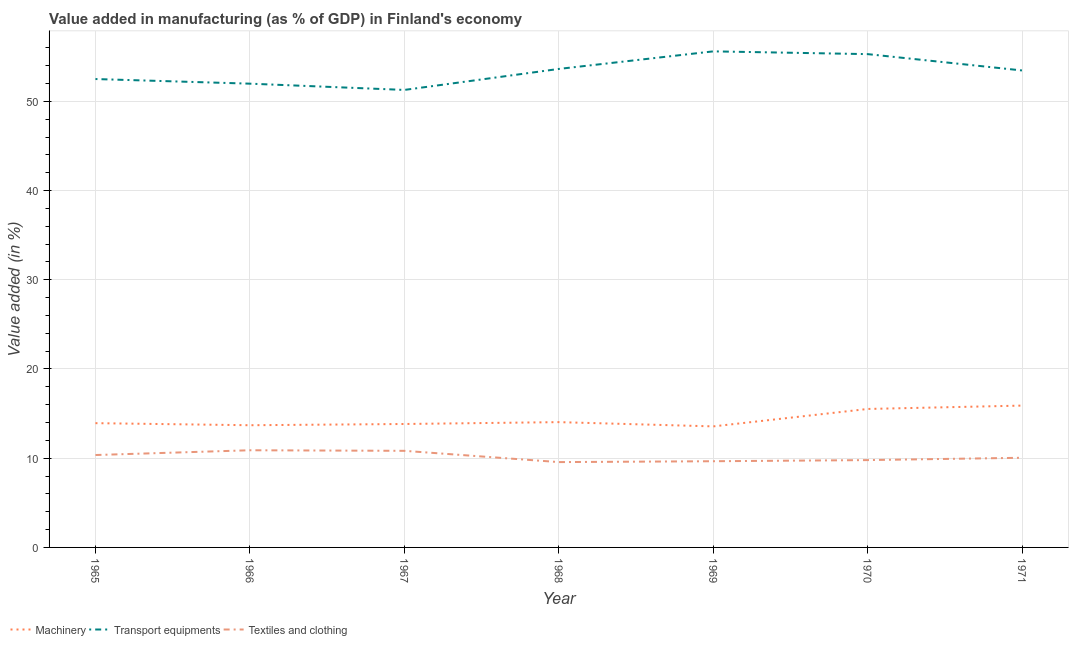What is the value added in manufacturing transport equipments in 1970?
Offer a very short reply. 55.29. Across all years, what is the maximum value added in manufacturing machinery?
Make the answer very short. 15.9. Across all years, what is the minimum value added in manufacturing textile and clothing?
Offer a terse response. 9.56. In which year was the value added in manufacturing textile and clothing maximum?
Provide a short and direct response. 1966. In which year was the value added in manufacturing textile and clothing minimum?
Your answer should be very brief. 1968. What is the total value added in manufacturing machinery in the graph?
Provide a short and direct response. 100.49. What is the difference between the value added in manufacturing machinery in 1966 and that in 1968?
Your response must be concise. -0.35. What is the difference between the value added in manufacturing machinery in 1966 and the value added in manufacturing transport equipments in 1969?
Offer a very short reply. -41.9. What is the average value added in manufacturing textile and clothing per year?
Provide a succinct answer. 10.16. In the year 1967, what is the difference between the value added in manufacturing textile and clothing and value added in manufacturing machinery?
Keep it short and to the point. -3.01. In how many years, is the value added in manufacturing machinery greater than 36 %?
Make the answer very short. 0. What is the ratio of the value added in manufacturing machinery in 1965 to that in 1968?
Your answer should be compact. 0.99. Is the difference between the value added in manufacturing machinery in 1966 and 1971 greater than the difference between the value added in manufacturing textile and clothing in 1966 and 1971?
Provide a succinct answer. No. What is the difference between the highest and the second highest value added in manufacturing textile and clothing?
Provide a short and direct response. 0.06. What is the difference between the highest and the lowest value added in manufacturing transport equipments?
Keep it short and to the point. 4.32. Is it the case that in every year, the sum of the value added in manufacturing machinery and value added in manufacturing transport equipments is greater than the value added in manufacturing textile and clothing?
Offer a terse response. Yes. Is the value added in manufacturing textile and clothing strictly less than the value added in manufacturing transport equipments over the years?
Offer a very short reply. Yes. Does the graph contain any zero values?
Provide a succinct answer. No. Does the graph contain grids?
Make the answer very short. Yes. Where does the legend appear in the graph?
Provide a short and direct response. Bottom left. How are the legend labels stacked?
Your answer should be compact. Horizontal. What is the title of the graph?
Provide a short and direct response. Value added in manufacturing (as % of GDP) in Finland's economy. Does "Secondary" appear as one of the legend labels in the graph?
Provide a succinct answer. No. What is the label or title of the X-axis?
Provide a succinct answer. Year. What is the label or title of the Y-axis?
Give a very brief answer. Value added (in %). What is the Value added (in %) of Machinery in 1965?
Make the answer very short. 13.93. What is the Value added (in %) in Transport equipments in 1965?
Your response must be concise. 52.5. What is the Value added (in %) in Textiles and clothing in 1965?
Your answer should be very brief. 10.36. What is the Value added (in %) of Machinery in 1966?
Give a very brief answer. 13.7. What is the Value added (in %) of Transport equipments in 1966?
Offer a terse response. 51.98. What is the Value added (in %) in Textiles and clothing in 1966?
Your response must be concise. 10.89. What is the Value added (in %) of Machinery in 1967?
Provide a short and direct response. 13.83. What is the Value added (in %) in Transport equipments in 1967?
Give a very brief answer. 51.28. What is the Value added (in %) in Textiles and clothing in 1967?
Keep it short and to the point. 10.83. What is the Value added (in %) of Machinery in 1968?
Your answer should be very brief. 14.04. What is the Value added (in %) in Transport equipments in 1968?
Your answer should be very brief. 53.63. What is the Value added (in %) in Textiles and clothing in 1968?
Offer a very short reply. 9.56. What is the Value added (in %) in Machinery in 1969?
Offer a terse response. 13.57. What is the Value added (in %) of Transport equipments in 1969?
Offer a very short reply. 55.6. What is the Value added (in %) in Textiles and clothing in 1969?
Your response must be concise. 9.66. What is the Value added (in %) in Machinery in 1970?
Give a very brief answer. 15.52. What is the Value added (in %) of Transport equipments in 1970?
Offer a terse response. 55.29. What is the Value added (in %) in Textiles and clothing in 1970?
Provide a succinct answer. 9.79. What is the Value added (in %) of Machinery in 1971?
Make the answer very short. 15.9. What is the Value added (in %) in Transport equipments in 1971?
Provide a short and direct response. 53.46. What is the Value added (in %) of Textiles and clothing in 1971?
Offer a very short reply. 10.05. Across all years, what is the maximum Value added (in %) in Machinery?
Offer a very short reply. 15.9. Across all years, what is the maximum Value added (in %) of Transport equipments?
Offer a very short reply. 55.6. Across all years, what is the maximum Value added (in %) in Textiles and clothing?
Your response must be concise. 10.89. Across all years, what is the minimum Value added (in %) in Machinery?
Your answer should be compact. 13.57. Across all years, what is the minimum Value added (in %) of Transport equipments?
Offer a very short reply. 51.28. Across all years, what is the minimum Value added (in %) in Textiles and clothing?
Keep it short and to the point. 9.56. What is the total Value added (in %) of Machinery in the graph?
Your response must be concise. 100.49. What is the total Value added (in %) of Transport equipments in the graph?
Your answer should be very brief. 373.74. What is the total Value added (in %) in Textiles and clothing in the graph?
Your answer should be very brief. 71.14. What is the difference between the Value added (in %) in Machinery in 1965 and that in 1966?
Provide a succinct answer. 0.23. What is the difference between the Value added (in %) of Transport equipments in 1965 and that in 1966?
Offer a very short reply. 0.52. What is the difference between the Value added (in %) in Textiles and clothing in 1965 and that in 1966?
Ensure brevity in your answer.  -0.53. What is the difference between the Value added (in %) in Machinery in 1965 and that in 1967?
Offer a terse response. 0.09. What is the difference between the Value added (in %) in Transport equipments in 1965 and that in 1967?
Ensure brevity in your answer.  1.22. What is the difference between the Value added (in %) of Textiles and clothing in 1965 and that in 1967?
Your answer should be very brief. -0.47. What is the difference between the Value added (in %) in Machinery in 1965 and that in 1968?
Your answer should be compact. -0.12. What is the difference between the Value added (in %) of Transport equipments in 1965 and that in 1968?
Offer a very short reply. -1.13. What is the difference between the Value added (in %) in Textiles and clothing in 1965 and that in 1968?
Ensure brevity in your answer.  0.79. What is the difference between the Value added (in %) of Machinery in 1965 and that in 1969?
Provide a short and direct response. 0.36. What is the difference between the Value added (in %) in Transport equipments in 1965 and that in 1969?
Your response must be concise. -3.1. What is the difference between the Value added (in %) in Textiles and clothing in 1965 and that in 1969?
Offer a terse response. 0.7. What is the difference between the Value added (in %) in Machinery in 1965 and that in 1970?
Provide a succinct answer. -1.59. What is the difference between the Value added (in %) of Transport equipments in 1965 and that in 1970?
Provide a succinct answer. -2.79. What is the difference between the Value added (in %) in Textiles and clothing in 1965 and that in 1970?
Give a very brief answer. 0.57. What is the difference between the Value added (in %) in Machinery in 1965 and that in 1971?
Provide a succinct answer. -1.97. What is the difference between the Value added (in %) of Transport equipments in 1965 and that in 1971?
Offer a terse response. -0.96. What is the difference between the Value added (in %) of Textiles and clothing in 1965 and that in 1971?
Keep it short and to the point. 0.31. What is the difference between the Value added (in %) of Machinery in 1966 and that in 1967?
Give a very brief answer. -0.14. What is the difference between the Value added (in %) of Transport equipments in 1966 and that in 1967?
Make the answer very short. 0.7. What is the difference between the Value added (in %) in Textiles and clothing in 1966 and that in 1967?
Your answer should be compact. 0.06. What is the difference between the Value added (in %) of Machinery in 1966 and that in 1968?
Your answer should be very brief. -0.35. What is the difference between the Value added (in %) of Transport equipments in 1966 and that in 1968?
Your answer should be very brief. -1.65. What is the difference between the Value added (in %) of Textiles and clothing in 1966 and that in 1968?
Offer a terse response. 1.33. What is the difference between the Value added (in %) in Machinery in 1966 and that in 1969?
Your answer should be very brief. 0.13. What is the difference between the Value added (in %) in Transport equipments in 1966 and that in 1969?
Give a very brief answer. -3.62. What is the difference between the Value added (in %) in Textiles and clothing in 1966 and that in 1969?
Make the answer very short. 1.23. What is the difference between the Value added (in %) in Machinery in 1966 and that in 1970?
Offer a very short reply. -1.82. What is the difference between the Value added (in %) of Transport equipments in 1966 and that in 1970?
Provide a succinct answer. -3.31. What is the difference between the Value added (in %) of Textiles and clothing in 1966 and that in 1970?
Provide a succinct answer. 1.1. What is the difference between the Value added (in %) in Machinery in 1966 and that in 1971?
Keep it short and to the point. -2.2. What is the difference between the Value added (in %) of Transport equipments in 1966 and that in 1971?
Provide a short and direct response. -1.48. What is the difference between the Value added (in %) in Textiles and clothing in 1966 and that in 1971?
Your answer should be compact. 0.84. What is the difference between the Value added (in %) of Machinery in 1967 and that in 1968?
Provide a short and direct response. -0.21. What is the difference between the Value added (in %) of Transport equipments in 1967 and that in 1968?
Offer a terse response. -2.35. What is the difference between the Value added (in %) of Textiles and clothing in 1967 and that in 1968?
Ensure brevity in your answer.  1.26. What is the difference between the Value added (in %) in Machinery in 1967 and that in 1969?
Make the answer very short. 0.27. What is the difference between the Value added (in %) of Transport equipments in 1967 and that in 1969?
Provide a succinct answer. -4.32. What is the difference between the Value added (in %) of Textiles and clothing in 1967 and that in 1969?
Offer a very short reply. 1.17. What is the difference between the Value added (in %) in Machinery in 1967 and that in 1970?
Your response must be concise. -1.69. What is the difference between the Value added (in %) in Transport equipments in 1967 and that in 1970?
Keep it short and to the point. -4.01. What is the difference between the Value added (in %) in Textiles and clothing in 1967 and that in 1970?
Your response must be concise. 1.04. What is the difference between the Value added (in %) of Machinery in 1967 and that in 1971?
Keep it short and to the point. -2.06. What is the difference between the Value added (in %) of Transport equipments in 1967 and that in 1971?
Keep it short and to the point. -2.18. What is the difference between the Value added (in %) in Textiles and clothing in 1967 and that in 1971?
Your response must be concise. 0.78. What is the difference between the Value added (in %) of Machinery in 1968 and that in 1969?
Provide a short and direct response. 0.48. What is the difference between the Value added (in %) in Transport equipments in 1968 and that in 1969?
Ensure brevity in your answer.  -1.97. What is the difference between the Value added (in %) in Textiles and clothing in 1968 and that in 1969?
Provide a short and direct response. -0.1. What is the difference between the Value added (in %) in Machinery in 1968 and that in 1970?
Offer a very short reply. -1.48. What is the difference between the Value added (in %) in Transport equipments in 1968 and that in 1970?
Offer a terse response. -1.66. What is the difference between the Value added (in %) of Textiles and clothing in 1968 and that in 1970?
Keep it short and to the point. -0.22. What is the difference between the Value added (in %) of Machinery in 1968 and that in 1971?
Your answer should be very brief. -1.85. What is the difference between the Value added (in %) of Transport equipments in 1968 and that in 1971?
Offer a very short reply. 0.17. What is the difference between the Value added (in %) in Textiles and clothing in 1968 and that in 1971?
Your answer should be compact. -0.49. What is the difference between the Value added (in %) in Machinery in 1969 and that in 1970?
Give a very brief answer. -1.95. What is the difference between the Value added (in %) of Transport equipments in 1969 and that in 1970?
Your answer should be very brief. 0.31. What is the difference between the Value added (in %) in Textiles and clothing in 1969 and that in 1970?
Offer a very short reply. -0.13. What is the difference between the Value added (in %) in Machinery in 1969 and that in 1971?
Provide a short and direct response. -2.33. What is the difference between the Value added (in %) of Transport equipments in 1969 and that in 1971?
Give a very brief answer. 2.14. What is the difference between the Value added (in %) of Textiles and clothing in 1969 and that in 1971?
Keep it short and to the point. -0.39. What is the difference between the Value added (in %) in Machinery in 1970 and that in 1971?
Ensure brevity in your answer.  -0.38. What is the difference between the Value added (in %) of Transport equipments in 1970 and that in 1971?
Ensure brevity in your answer.  1.83. What is the difference between the Value added (in %) in Textiles and clothing in 1970 and that in 1971?
Provide a succinct answer. -0.26. What is the difference between the Value added (in %) in Machinery in 1965 and the Value added (in %) in Transport equipments in 1966?
Provide a short and direct response. -38.05. What is the difference between the Value added (in %) in Machinery in 1965 and the Value added (in %) in Textiles and clothing in 1966?
Make the answer very short. 3.04. What is the difference between the Value added (in %) of Transport equipments in 1965 and the Value added (in %) of Textiles and clothing in 1966?
Your answer should be compact. 41.61. What is the difference between the Value added (in %) of Machinery in 1965 and the Value added (in %) of Transport equipments in 1967?
Give a very brief answer. -37.35. What is the difference between the Value added (in %) in Machinery in 1965 and the Value added (in %) in Textiles and clothing in 1967?
Your response must be concise. 3.1. What is the difference between the Value added (in %) in Transport equipments in 1965 and the Value added (in %) in Textiles and clothing in 1967?
Your answer should be very brief. 41.67. What is the difference between the Value added (in %) in Machinery in 1965 and the Value added (in %) in Transport equipments in 1968?
Your response must be concise. -39.7. What is the difference between the Value added (in %) in Machinery in 1965 and the Value added (in %) in Textiles and clothing in 1968?
Keep it short and to the point. 4.36. What is the difference between the Value added (in %) of Transport equipments in 1965 and the Value added (in %) of Textiles and clothing in 1968?
Provide a short and direct response. 42.94. What is the difference between the Value added (in %) of Machinery in 1965 and the Value added (in %) of Transport equipments in 1969?
Give a very brief answer. -41.67. What is the difference between the Value added (in %) of Machinery in 1965 and the Value added (in %) of Textiles and clothing in 1969?
Your answer should be very brief. 4.27. What is the difference between the Value added (in %) in Transport equipments in 1965 and the Value added (in %) in Textiles and clothing in 1969?
Make the answer very short. 42.84. What is the difference between the Value added (in %) in Machinery in 1965 and the Value added (in %) in Transport equipments in 1970?
Keep it short and to the point. -41.36. What is the difference between the Value added (in %) in Machinery in 1965 and the Value added (in %) in Textiles and clothing in 1970?
Offer a terse response. 4.14. What is the difference between the Value added (in %) of Transport equipments in 1965 and the Value added (in %) of Textiles and clothing in 1970?
Offer a very short reply. 42.71. What is the difference between the Value added (in %) in Machinery in 1965 and the Value added (in %) in Transport equipments in 1971?
Your answer should be compact. -39.53. What is the difference between the Value added (in %) in Machinery in 1965 and the Value added (in %) in Textiles and clothing in 1971?
Keep it short and to the point. 3.88. What is the difference between the Value added (in %) in Transport equipments in 1965 and the Value added (in %) in Textiles and clothing in 1971?
Your answer should be very brief. 42.45. What is the difference between the Value added (in %) in Machinery in 1966 and the Value added (in %) in Transport equipments in 1967?
Ensure brevity in your answer.  -37.58. What is the difference between the Value added (in %) of Machinery in 1966 and the Value added (in %) of Textiles and clothing in 1967?
Make the answer very short. 2.87. What is the difference between the Value added (in %) of Transport equipments in 1966 and the Value added (in %) of Textiles and clothing in 1967?
Provide a succinct answer. 41.15. What is the difference between the Value added (in %) of Machinery in 1966 and the Value added (in %) of Transport equipments in 1968?
Your response must be concise. -39.94. What is the difference between the Value added (in %) of Machinery in 1966 and the Value added (in %) of Textiles and clothing in 1968?
Keep it short and to the point. 4.13. What is the difference between the Value added (in %) of Transport equipments in 1966 and the Value added (in %) of Textiles and clothing in 1968?
Your response must be concise. 42.42. What is the difference between the Value added (in %) in Machinery in 1966 and the Value added (in %) in Transport equipments in 1969?
Offer a very short reply. -41.9. What is the difference between the Value added (in %) of Machinery in 1966 and the Value added (in %) of Textiles and clothing in 1969?
Provide a short and direct response. 4.04. What is the difference between the Value added (in %) of Transport equipments in 1966 and the Value added (in %) of Textiles and clothing in 1969?
Offer a terse response. 42.32. What is the difference between the Value added (in %) of Machinery in 1966 and the Value added (in %) of Transport equipments in 1970?
Provide a short and direct response. -41.59. What is the difference between the Value added (in %) in Machinery in 1966 and the Value added (in %) in Textiles and clothing in 1970?
Your answer should be compact. 3.91. What is the difference between the Value added (in %) of Transport equipments in 1966 and the Value added (in %) of Textiles and clothing in 1970?
Provide a succinct answer. 42.19. What is the difference between the Value added (in %) of Machinery in 1966 and the Value added (in %) of Transport equipments in 1971?
Your answer should be compact. -39.76. What is the difference between the Value added (in %) in Machinery in 1966 and the Value added (in %) in Textiles and clothing in 1971?
Give a very brief answer. 3.65. What is the difference between the Value added (in %) of Transport equipments in 1966 and the Value added (in %) of Textiles and clothing in 1971?
Provide a succinct answer. 41.93. What is the difference between the Value added (in %) in Machinery in 1967 and the Value added (in %) in Transport equipments in 1968?
Keep it short and to the point. -39.8. What is the difference between the Value added (in %) of Machinery in 1967 and the Value added (in %) of Textiles and clothing in 1968?
Your response must be concise. 4.27. What is the difference between the Value added (in %) of Transport equipments in 1967 and the Value added (in %) of Textiles and clothing in 1968?
Ensure brevity in your answer.  41.71. What is the difference between the Value added (in %) of Machinery in 1967 and the Value added (in %) of Transport equipments in 1969?
Keep it short and to the point. -41.77. What is the difference between the Value added (in %) of Machinery in 1967 and the Value added (in %) of Textiles and clothing in 1969?
Provide a short and direct response. 4.17. What is the difference between the Value added (in %) in Transport equipments in 1967 and the Value added (in %) in Textiles and clothing in 1969?
Make the answer very short. 41.62. What is the difference between the Value added (in %) in Machinery in 1967 and the Value added (in %) in Transport equipments in 1970?
Give a very brief answer. -41.46. What is the difference between the Value added (in %) in Machinery in 1967 and the Value added (in %) in Textiles and clothing in 1970?
Keep it short and to the point. 4.05. What is the difference between the Value added (in %) of Transport equipments in 1967 and the Value added (in %) of Textiles and clothing in 1970?
Keep it short and to the point. 41.49. What is the difference between the Value added (in %) of Machinery in 1967 and the Value added (in %) of Transport equipments in 1971?
Give a very brief answer. -39.63. What is the difference between the Value added (in %) of Machinery in 1967 and the Value added (in %) of Textiles and clothing in 1971?
Keep it short and to the point. 3.79. What is the difference between the Value added (in %) of Transport equipments in 1967 and the Value added (in %) of Textiles and clothing in 1971?
Ensure brevity in your answer.  41.23. What is the difference between the Value added (in %) in Machinery in 1968 and the Value added (in %) in Transport equipments in 1969?
Make the answer very short. -41.56. What is the difference between the Value added (in %) in Machinery in 1968 and the Value added (in %) in Textiles and clothing in 1969?
Your answer should be compact. 4.38. What is the difference between the Value added (in %) of Transport equipments in 1968 and the Value added (in %) of Textiles and clothing in 1969?
Ensure brevity in your answer.  43.97. What is the difference between the Value added (in %) in Machinery in 1968 and the Value added (in %) in Transport equipments in 1970?
Offer a terse response. -41.25. What is the difference between the Value added (in %) in Machinery in 1968 and the Value added (in %) in Textiles and clothing in 1970?
Provide a short and direct response. 4.26. What is the difference between the Value added (in %) in Transport equipments in 1968 and the Value added (in %) in Textiles and clothing in 1970?
Ensure brevity in your answer.  43.84. What is the difference between the Value added (in %) in Machinery in 1968 and the Value added (in %) in Transport equipments in 1971?
Provide a short and direct response. -39.42. What is the difference between the Value added (in %) of Machinery in 1968 and the Value added (in %) of Textiles and clothing in 1971?
Your response must be concise. 3.99. What is the difference between the Value added (in %) in Transport equipments in 1968 and the Value added (in %) in Textiles and clothing in 1971?
Your answer should be very brief. 43.58. What is the difference between the Value added (in %) in Machinery in 1969 and the Value added (in %) in Transport equipments in 1970?
Your response must be concise. -41.72. What is the difference between the Value added (in %) in Machinery in 1969 and the Value added (in %) in Textiles and clothing in 1970?
Provide a short and direct response. 3.78. What is the difference between the Value added (in %) of Transport equipments in 1969 and the Value added (in %) of Textiles and clothing in 1970?
Make the answer very short. 45.81. What is the difference between the Value added (in %) in Machinery in 1969 and the Value added (in %) in Transport equipments in 1971?
Your answer should be very brief. -39.89. What is the difference between the Value added (in %) in Machinery in 1969 and the Value added (in %) in Textiles and clothing in 1971?
Keep it short and to the point. 3.52. What is the difference between the Value added (in %) in Transport equipments in 1969 and the Value added (in %) in Textiles and clothing in 1971?
Ensure brevity in your answer.  45.55. What is the difference between the Value added (in %) in Machinery in 1970 and the Value added (in %) in Transport equipments in 1971?
Your answer should be very brief. -37.94. What is the difference between the Value added (in %) in Machinery in 1970 and the Value added (in %) in Textiles and clothing in 1971?
Provide a succinct answer. 5.47. What is the difference between the Value added (in %) in Transport equipments in 1970 and the Value added (in %) in Textiles and clothing in 1971?
Provide a succinct answer. 45.24. What is the average Value added (in %) in Machinery per year?
Offer a very short reply. 14.36. What is the average Value added (in %) of Transport equipments per year?
Provide a short and direct response. 53.39. What is the average Value added (in %) in Textiles and clothing per year?
Ensure brevity in your answer.  10.16. In the year 1965, what is the difference between the Value added (in %) in Machinery and Value added (in %) in Transport equipments?
Offer a terse response. -38.57. In the year 1965, what is the difference between the Value added (in %) of Machinery and Value added (in %) of Textiles and clothing?
Keep it short and to the point. 3.57. In the year 1965, what is the difference between the Value added (in %) of Transport equipments and Value added (in %) of Textiles and clothing?
Your response must be concise. 42.14. In the year 1966, what is the difference between the Value added (in %) in Machinery and Value added (in %) in Transport equipments?
Give a very brief answer. -38.28. In the year 1966, what is the difference between the Value added (in %) in Machinery and Value added (in %) in Textiles and clothing?
Your response must be concise. 2.81. In the year 1966, what is the difference between the Value added (in %) in Transport equipments and Value added (in %) in Textiles and clothing?
Keep it short and to the point. 41.09. In the year 1967, what is the difference between the Value added (in %) of Machinery and Value added (in %) of Transport equipments?
Provide a succinct answer. -37.44. In the year 1967, what is the difference between the Value added (in %) of Machinery and Value added (in %) of Textiles and clothing?
Offer a very short reply. 3.01. In the year 1967, what is the difference between the Value added (in %) of Transport equipments and Value added (in %) of Textiles and clothing?
Offer a very short reply. 40.45. In the year 1968, what is the difference between the Value added (in %) of Machinery and Value added (in %) of Transport equipments?
Provide a succinct answer. -39.59. In the year 1968, what is the difference between the Value added (in %) of Machinery and Value added (in %) of Textiles and clothing?
Provide a short and direct response. 4.48. In the year 1968, what is the difference between the Value added (in %) in Transport equipments and Value added (in %) in Textiles and clothing?
Your answer should be very brief. 44.07. In the year 1969, what is the difference between the Value added (in %) of Machinery and Value added (in %) of Transport equipments?
Offer a very short reply. -42.03. In the year 1969, what is the difference between the Value added (in %) of Machinery and Value added (in %) of Textiles and clothing?
Give a very brief answer. 3.91. In the year 1969, what is the difference between the Value added (in %) of Transport equipments and Value added (in %) of Textiles and clothing?
Provide a succinct answer. 45.94. In the year 1970, what is the difference between the Value added (in %) in Machinery and Value added (in %) in Transport equipments?
Your answer should be compact. -39.77. In the year 1970, what is the difference between the Value added (in %) of Machinery and Value added (in %) of Textiles and clothing?
Offer a terse response. 5.73. In the year 1970, what is the difference between the Value added (in %) of Transport equipments and Value added (in %) of Textiles and clothing?
Provide a succinct answer. 45.5. In the year 1971, what is the difference between the Value added (in %) of Machinery and Value added (in %) of Transport equipments?
Give a very brief answer. -37.56. In the year 1971, what is the difference between the Value added (in %) of Machinery and Value added (in %) of Textiles and clothing?
Your answer should be very brief. 5.85. In the year 1971, what is the difference between the Value added (in %) of Transport equipments and Value added (in %) of Textiles and clothing?
Provide a short and direct response. 43.41. What is the ratio of the Value added (in %) in Machinery in 1965 to that in 1966?
Provide a succinct answer. 1.02. What is the ratio of the Value added (in %) of Transport equipments in 1965 to that in 1966?
Give a very brief answer. 1.01. What is the ratio of the Value added (in %) in Textiles and clothing in 1965 to that in 1966?
Your response must be concise. 0.95. What is the ratio of the Value added (in %) in Machinery in 1965 to that in 1967?
Your response must be concise. 1.01. What is the ratio of the Value added (in %) of Transport equipments in 1965 to that in 1967?
Offer a terse response. 1.02. What is the ratio of the Value added (in %) in Textiles and clothing in 1965 to that in 1967?
Your answer should be compact. 0.96. What is the ratio of the Value added (in %) of Transport equipments in 1965 to that in 1968?
Give a very brief answer. 0.98. What is the ratio of the Value added (in %) of Textiles and clothing in 1965 to that in 1968?
Provide a short and direct response. 1.08. What is the ratio of the Value added (in %) of Machinery in 1965 to that in 1969?
Offer a very short reply. 1.03. What is the ratio of the Value added (in %) of Transport equipments in 1965 to that in 1969?
Keep it short and to the point. 0.94. What is the ratio of the Value added (in %) in Textiles and clothing in 1965 to that in 1969?
Ensure brevity in your answer.  1.07. What is the ratio of the Value added (in %) in Machinery in 1965 to that in 1970?
Give a very brief answer. 0.9. What is the ratio of the Value added (in %) in Transport equipments in 1965 to that in 1970?
Give a very brief answer. 0.95. What is the ratio of the Value added (in %) in Textiles and clothing in 1965 to that in 1970?
Offer a very short reply. 1.06. What is the ratio of the Value added (in %) of Machinery in 1965 to that in 1971?
Offer a terse response. 0.88. What is the ratio of the Value added (in %) in Transport equipments in 1965 to that in 1971?
Offer a terse response. 0.98. What is the ratio of the Value added (in %) of Textiles and clothing in 1965 to that in 1971?
Keep it short and to the point. 1.03. What is the ratio of the Value added (in %) of Transport equipments in 1966 to that in 1967?
Your answer should be very brief. 1.01. What is the ratio of the Value added (in %) of Textiles and clothing in 1966 to that in 1967?
Your response must be concise. 1.01. What is the ratio of the Value added (in %) of Machinery in 1966 to that in 1968?
Ensure brevity in your answer.  0.98. What is the ratio of the Value added (in %) of Transport equipments in 1966 to that in 1968?
Make the answer very short. 0.97. What is the ratio of the Value added (in %) in Textiles and clothing in 1966 to that in 1968?
Your answer should be very brief. 1.14. What is the ratio of the Value added (in %) in Machinery in 1966 to that in 1969?
Give a very brief answer. 1.01. What is the ratio of the Value added (in %) of Transport equipments in 1966 to that in 1969?
Make the answer very short. 0.93. What is the ratio of the Value added (in %) in Textiles and clothing in 1966 to that in 1969?
Give a very brief answer. 1.13. What is the ratio of the Value added (in %) in Machinery in 1966 to that in 1970?
Your response must be concise. 0.88. What is the ratio of the Value added (in %) of Transport equipments in 1966 to that in 1970?
Keep it short and to the point. 0.94. What is the ratio of the Value added (in %) in Textiles and clothing in 1966 to that in 1970?
Give a very brief answer. 1.11. What is the ratio of the Value added (in %) in Machinery in 1966 to that in 1971?
Your answer should be very brief. 0.86. What is the ratio of the Value added (in %) of Transport equipments in 1966 to that in 1971?
Give a very brief answer. 0.97. What is the ratio of the Value added (in %) in Textiles and clothing in 1966 to that in 1971?
Make the answer very short. 1.08. What is the ratio of the Value added (in %) in Machinery in 1967 to that in 1968?
Offer a very short reply. 0.99. What is the ratio of the Value added (in %) of Transport equipments in 1967 to that in 1968?
Provide a succinct answer. 0.96. What is the ratio of the Value added (in %) in Textiles and clothing in 1967 to that in 1968?
Give a very brief answer. 1.13. What is the ratio of the Value added (in %) of Machinery in 1967 to that in 1969?
Provide a short and direct response. 1.02. What is the ratio of the Value added (in %) of Transport equipments in 1967 to that in 1969?
Offer a terse response. 0.92. What is the ratio of the Value added (in %) in Textiles and clothing in 1967 to that in 1969?
Make the answer very short. 1.12. What is the ratio of the Value added (in %) in Machinery in 1967 to that in 1970?
Provide a short and direct response. 0.89. What is the ratio of the Value added (in %) in Transport equipments in 1967 to that in 1970?
Keep it short and to the point. 0.93. What is the ratio of the Value added (in %) in Textiles and clothing in 1967 to that in 1970?
Ensure brevity in your answer.  1.11. What is the ratio of the Value added (in %) of Machinery in 1967 to that in 1971?
Offer a very short reply. 0.87. What is the ratio of the Value added (in %) of Transport equipments in 1967 to that in 1971?
Provide a succinct answer. 0.96. What is the ratio of the Value added (in %) in Textiles and clothing in 1967 to that in 1971?
Give a very brief answer. 1.08. What is the ratio of the Value added (in %) in Machinery in 1968 to that in 1969?
Your answer should be very brief. 1.04. What is the ratio of the Value added (in %) of Transport equipments in 1968 to that in 1969?
Offer a terse response. 0.96. What is the ratio of the Value added (in %) in Textiles and clothing in 1968 to that in 1969?
Your answer should be compact. 0.99. What is the ratio of the Value added (in %) in Machinery in 1968 to that in 1970?
Give a very brief answer. 0.9. What is the ratio of the Value added (in %) in Textiles and clothing in 1968 to that in 1970?
Make the answer very short. 0.98. What is the ratio of the Value added (in %) of Machinery in 1968 to that in 1971?
Your answer should be compact. 0.88. What is the ratio of the Value added (in %) in Textiles and clothing in 1968 to that in 1971?
Ensure brevity in your answer.  0.95. What is the ratio of the Value added (in %) in Machinery in 1969 to that in 1970?
Your response must be concise. 0.87. What is the ratio of the Value added (in %) of Transport equipments in 1969 to that in 1970?
Make the answer very short. 1.01. What is the ratio of the Value added (in %) in Machinery in 1969 to that in 1971?
Offer a very short reply. 0.85. What is the ratio of the Value added (in %) of Transport equipments in 1969 to that in 1971?
Ensure brevity in your answer.  1.04. What is the ratio of the Value added (in %) in Textiles and clothing in 1969 to that in 1971?
Your answer should be compact. 0.96. What is the ratio of the Value added (in %) of Machinery in 1970 to that in 1971?
Provide a short and direct response. 0.98. What is the ratio of the Value added (in %) of Transport equipments in 1970 to that in 1971?
Your response must be concise. 1.03. What is the ratio of the Value added (in %) in Textiles and clothing in 1970 to that in 1971?
Provide a succinct answer. 0.97. What is the difference between the highest and the second highest Value added (in %) of Machinery?
Make the answer very short. 0.38. What is the difference between the highest and the second highest Value added (in %) of Transport equipments?
Provide a succinct answer. 0.31. What is the difference between the highest and the second highest Value added (in %) of Textiles and clothing?
Your answer should be compact. 0.06. What is the difference between the highest and the lowest Value added (in %) in Machinery?
Keep it short and to the point. 2.33. What is the difference between the highest and the lowest Value added (in %) in Transport equipments?
Your answer should be very brief. 4.32. What is the difference between the highest and the lowest Value added (in %) in Textiles and clothing?
Offer a terse response. 1.33. 